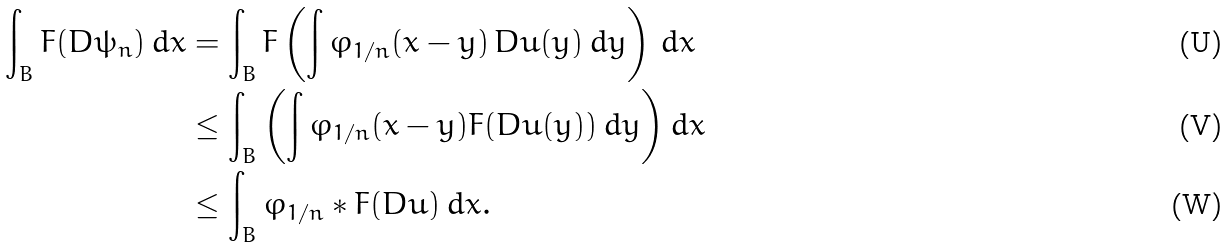<formula> <loc_0><loc_0><loc_500><loc_500>\int _ { B } F ( D \psi _ { n } ) \, d x & = \int _ { B } F \left ( \int \varphi _ { 1 / n } ( x - y ) \, D u ( y ) \, d y \right ) \, d x \\ & \leq \int _ { B } \left ( \int \varphi _ { 1 / n } ( x - y ) F ( D u ( y ) ) \, d y \right ) d x \\ & \leq \int _ { B } \varphi _ { 1 / n } * F ( D u ) \, d x .</formula> 